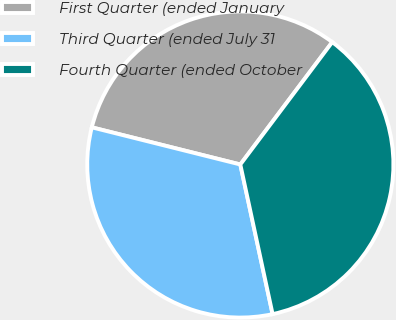Convert chart. <chart><loc_0><loc_0><loc_500><loc_500><pie_chart><fcel>First Quarter (ended January<fcel>Third Quarter (ended July 31<fcel>Fourth Quarter (ended October<nl><fcel>31.35%<fcel>32.28%<fcel>36.36%<nl></chart> 